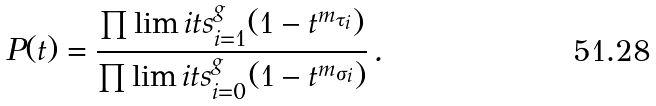<formula> <loc_0><loc_0><loc_500><loc_500>P ( t ) = \frac { \prod \lim i t s _ { i = 1 } ^ { g } ( 1 - t ^ { m _ { \tau _ { i } } } ) } { \prod \lim i t s _ { i = 0 } ^ { g } ( 1 - t ^ { m _ { \sigma _ { i } } } ) } \, .</formula> 